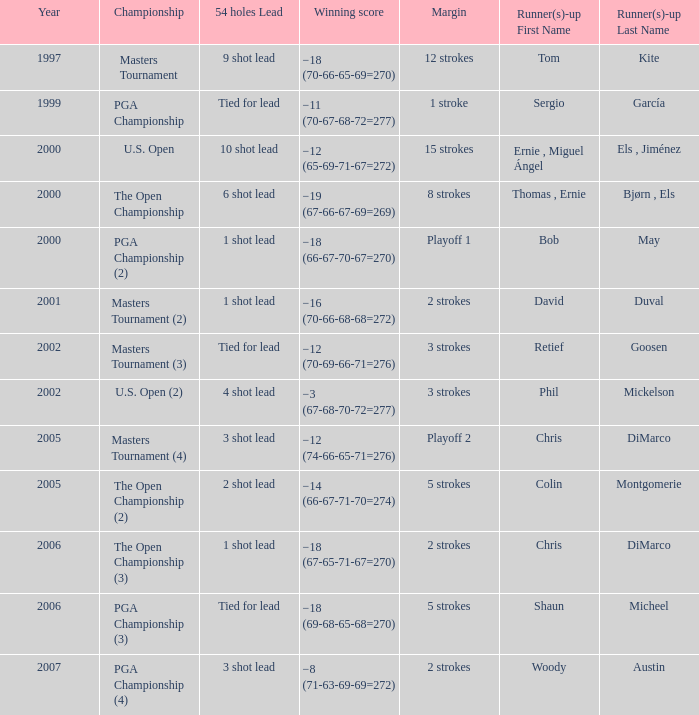 who is the runner(s)-up where 54 holes is tied for lead and margin is 5 strokes Shaun Micheel. 